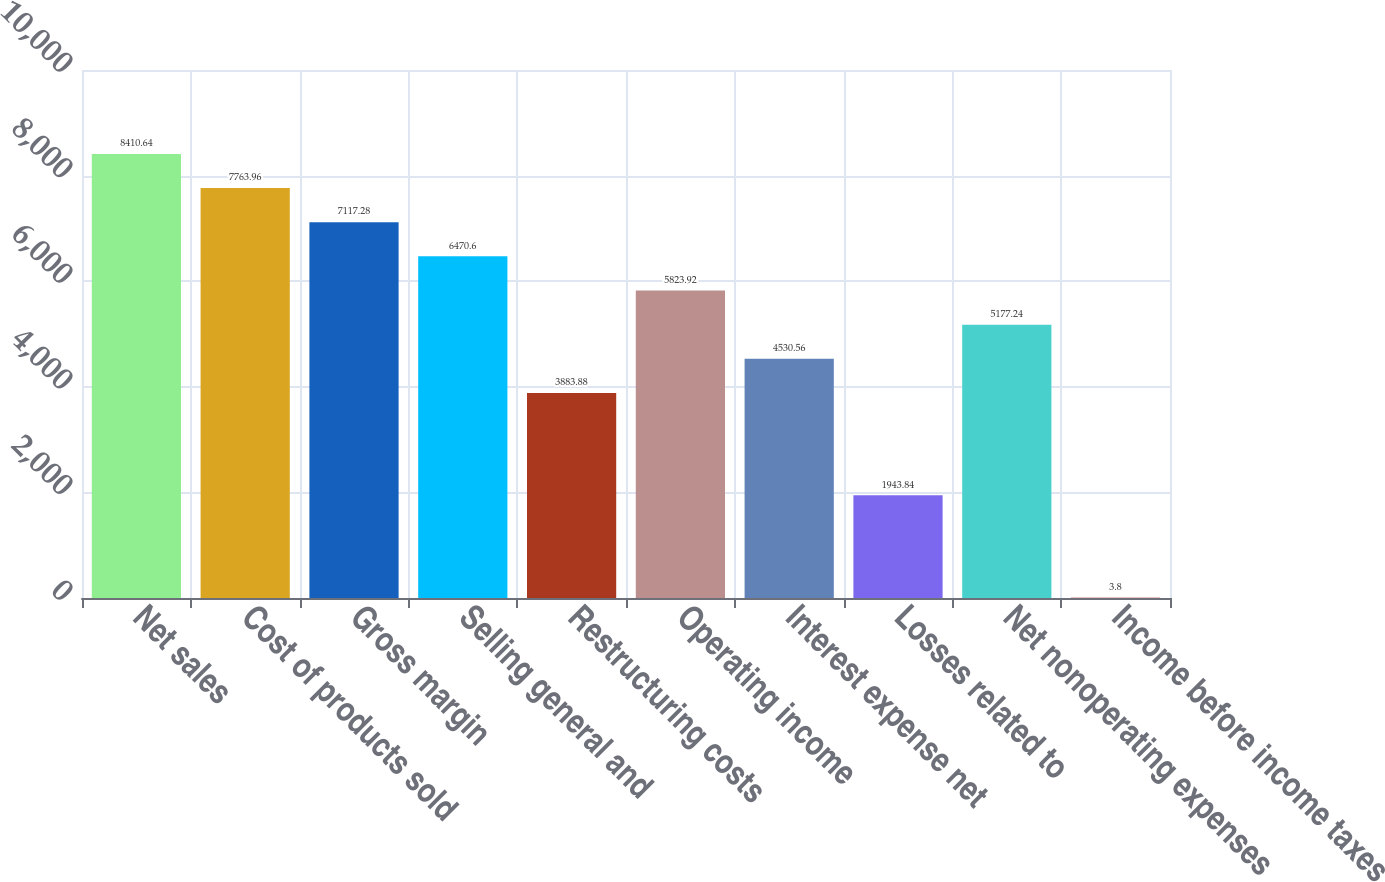<chart> <loc_0><loc_0><loc_500><loc_500><bar_chart><fcel>Net sales<fcel>Cost of products sold<fcel>Gross margin<fcel>Selling general and<fcel>Restructuring costs<fcel>Operating income<fcel>Interest expense net<fcel>Losses related to<fcel>Net nonoperating expenses<fcel>Income before income taxes<nl><fcel>8410.64<fcel>7763.96<fcel>7117.28<fcel>6470.6<fcel>3883.88<fcel>5823.92<fcel>4530.56<fcel>1943.84<fcel>5177.24<fcel>3.8<nl></chart> 